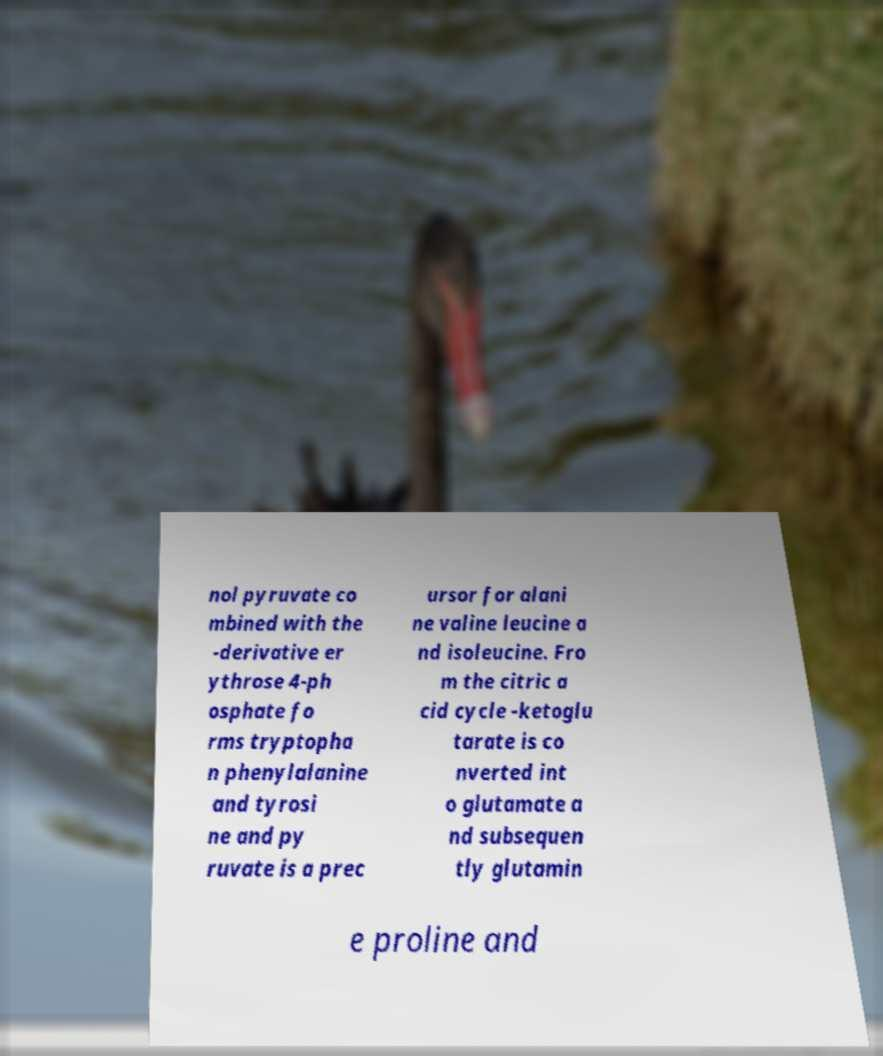Could you extract and type out the text from this image? nol pyruvate co mbined with the -derivative er ythrose 4-ph osphate fo rms tryptopha n phenylalanine and tyrosi ne and py ruvate is a prec ursor for alani ne valine leucine a nd isoleucine. Fro m the citric a cid cycle -ketoglu tarate is co nverted int o glutamate a nd subsequen tly glutamin e proline and 